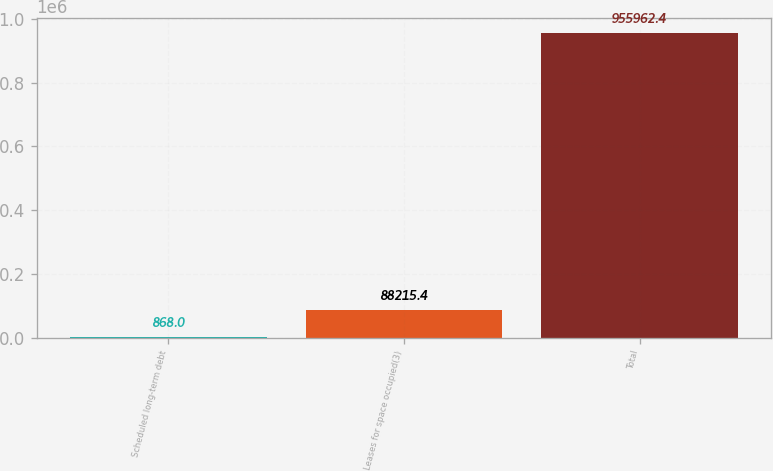Convert chart. <chart><loc_0><loc_0><loc_500><loc_500><bar_chart><fcel>Scheduled long-term debt<fcel>Leases for space occupied(3)<fcel>Total<nl><fcel>868<fcel>88215.4<fcel>955962<nl></chart> 